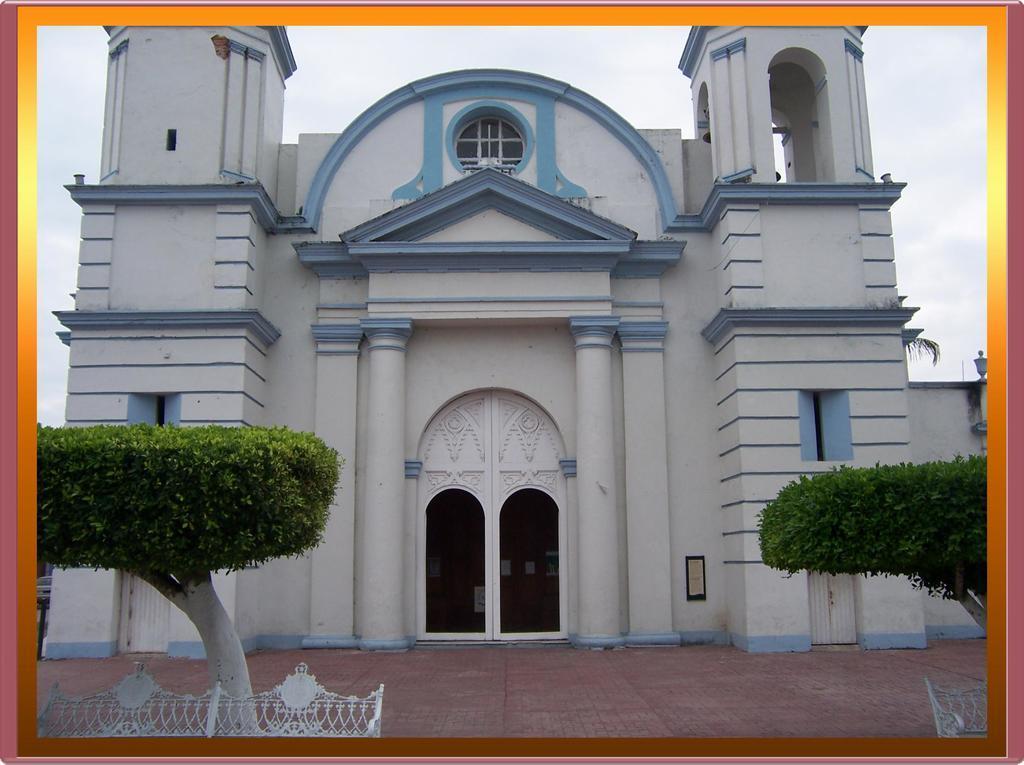Describe this image in one or two sentences. In the picture I can see a building, trees, fence and doors. In the background I can see the sky. 